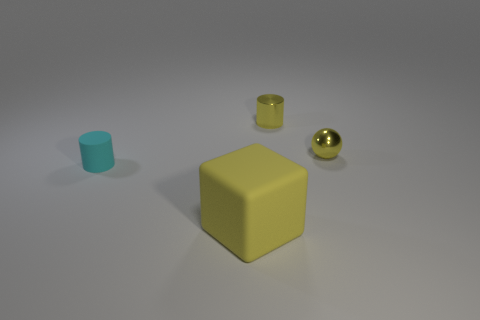Add 2 red rubber blocks. How many objects exist? 6 Subtract all cubes. How many objects are left? 3 Add 4 matte objects. How many matte objects are left? 6 Add 1 small cyan things. How many small cyan things exist? 2 Subtract 0 blue spheres. How many objects are left? 4 Subtract all yellow balls. Subtract all cyan metal cubes. How many objects are left? 3 